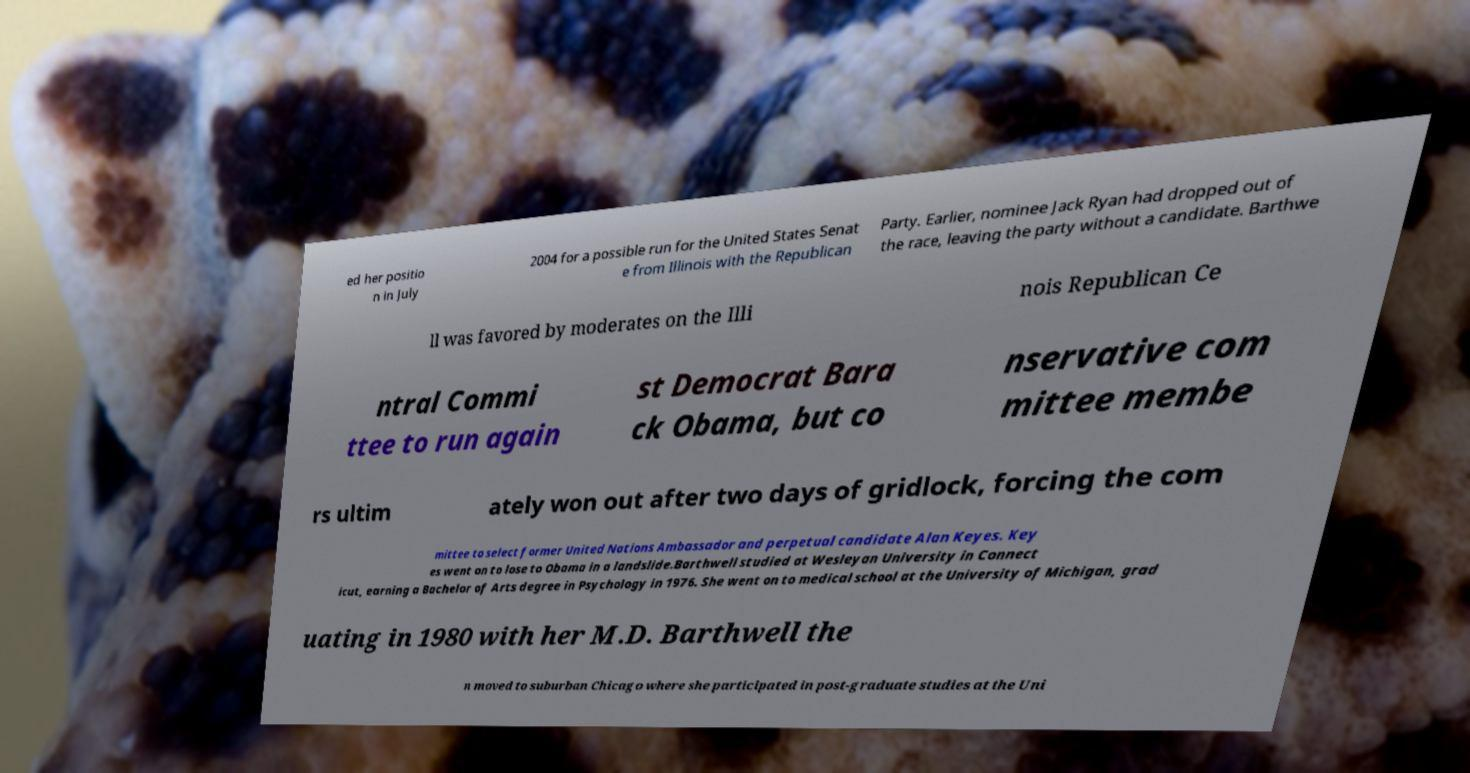Please identify and transcribe the text found in this image. ed her positio n in July 2004 for a possible run for the United States Senat e from Illinois with the Republican Party. Earlier, nominee Jack Ryan had dropped out of the race, leaving the party without a candidate. Barthwe ll was favored by moderates on the Illi nois Republican Ce ntral Commi ttee to run again st Democrat Bara ck Obama, but co nservative com mittee membe rs ultim ately won out after two days of gridlock, forcing the com mittee to select former United Nations Ambassador and perpetual candidate Alan Keyes. Key es went on to lose to Obama in a landslide.Barthwell studied at Wesleyan University in Connect icut, earning a Bachelor of Arts degree in Psychology in 1976. She went on to medical school at the University of Michigan, grad uating in 1980 with her M.D. Barthwell the n moved to suburban Chicago where she participated in post-graduate studies at the Uni 